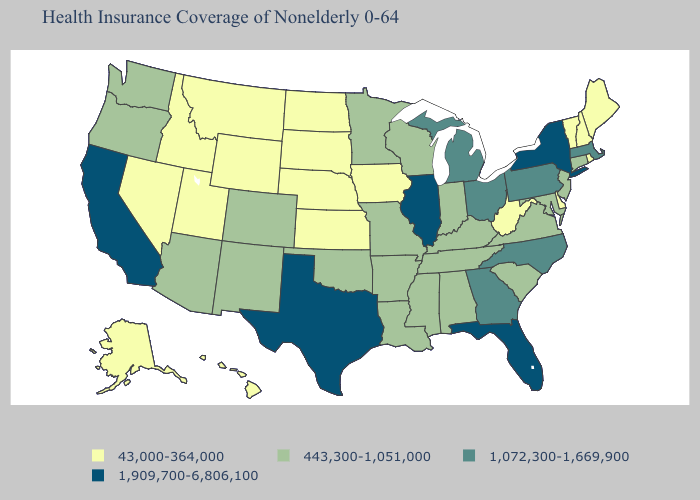What is the value of Missouri?
Keep it brief. 443,300-1,051,000. Among the states that border California , does Arizona have the lowest value?
Quick response, please. No. What is the value of Minnesota?
Answer briefly. 443,300-1,051,000. Does the first symbol in the legend represent the smallest category?
Be succinct. Yes. Which states hav the highest value in the West?
Concise answer only. California. Does West Virginia have the lowest value in the South?
Quick response, please. Yes. Name the states that have a value in the range 1,909,700-6,806,100?
Short answer required. California, Florida, Illinois, New York, Texas. What is the value of Georgia?
Be succinct. 1,072,300-1,669,900. What is the value of Washington?
Be succinct. 443,300-1,051,000. Which states have the lowest value in the West?
Give a very brief answer. Alaska, Hawaii, Idaho, Montana, Nevada, Utah, Wyoming. Which states hav the highest value in the South?
Answer briefly. Florida, Texas. Does South Carolina have the lowest value in the South?
Quick response, please. No. Among the states that border Kansas , does Colorado have the lowest value?
Write a very short answer. No. Name the states that have a value in the range 1,072,300-1,669,900?
Give a very brief answer. Georgia, Massachusetts, Michigan, North Carolina, Ohio, Pennsylvania. 